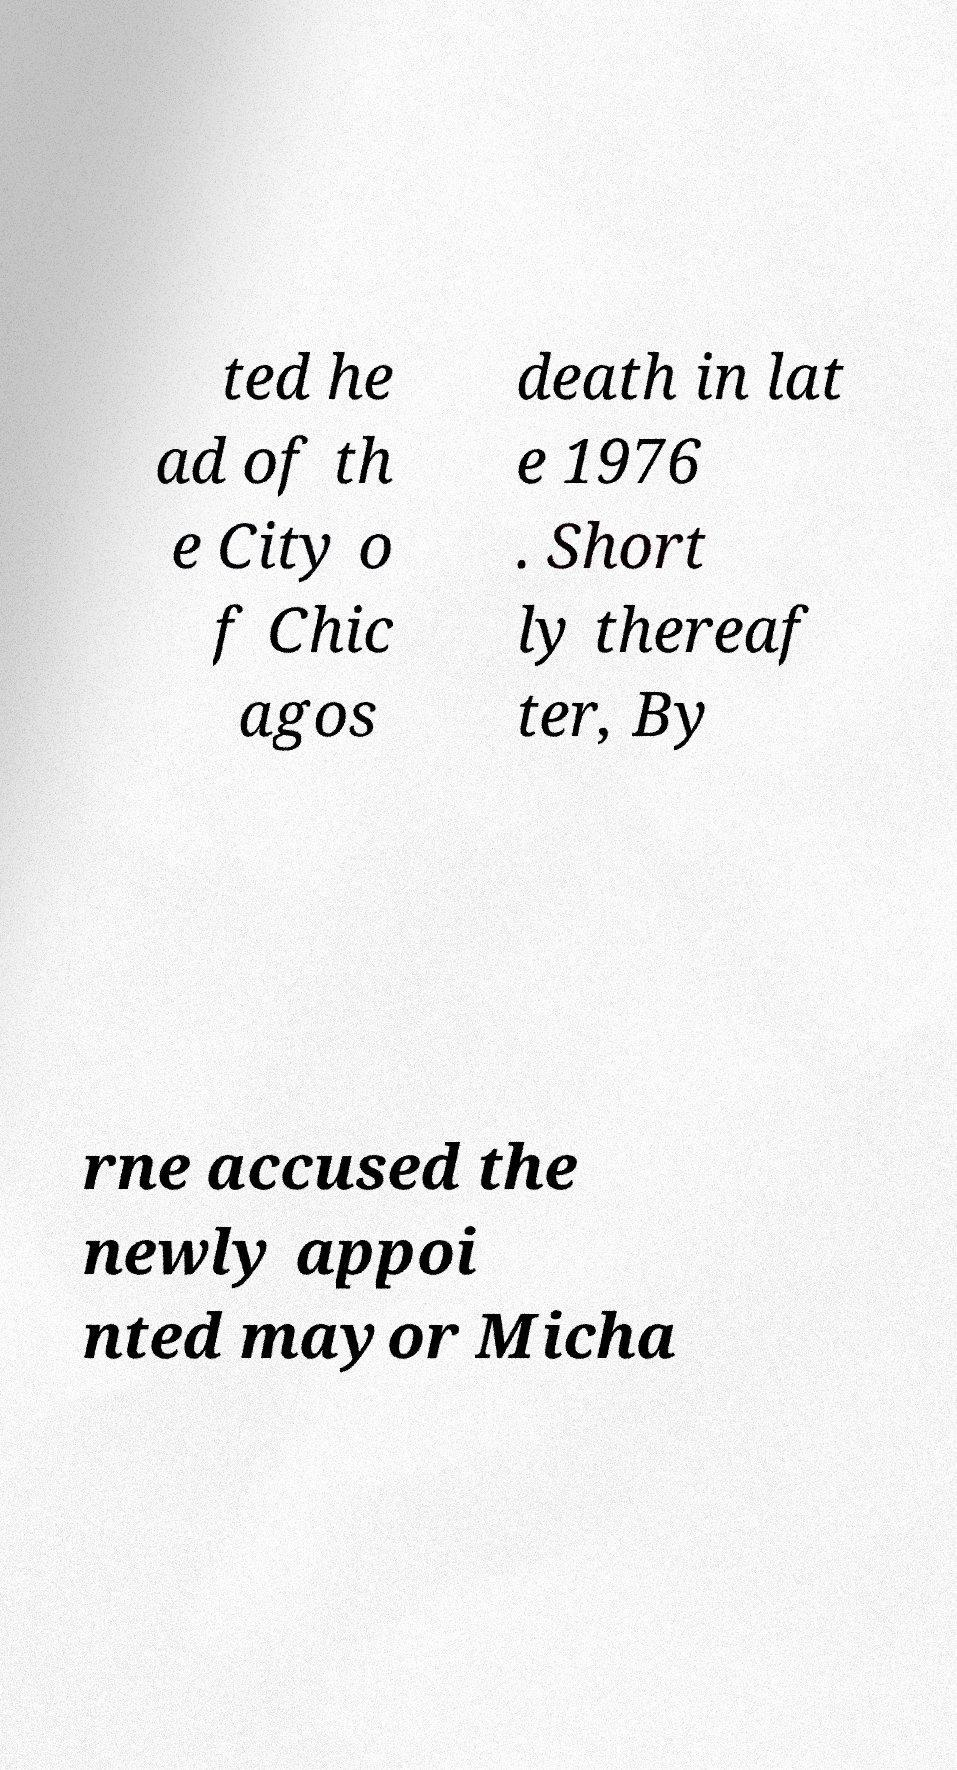There's text embedded in this image that I need extracted. Can you transcribe it verbatim? ted he ad of th e City o f Chic agos death in lat e 1976 . Short ly thereaf ter, By rne accused the newly appoi nted mayor Micha 